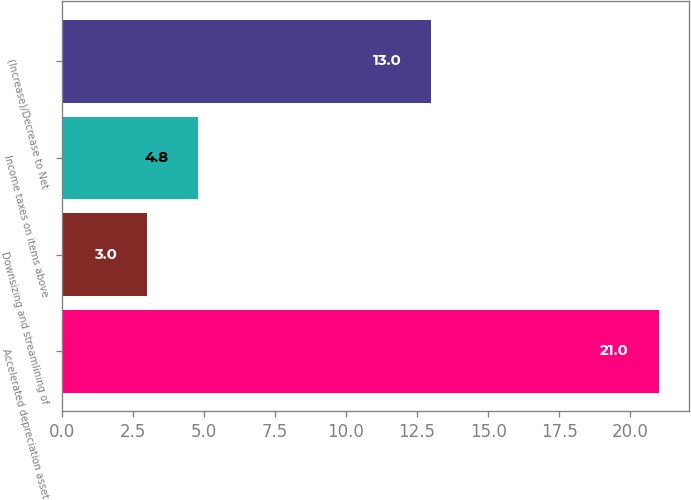Convert chart. <chart><loc_0><loc_0><loc_500><loc_500><bar_chart><fcel>Accelerated depreciation asset<fcel>Downsizing and streamlining of<fcel>Income taxes on items above<fcel>(Increase)/Decrease to Net<nl><fcel>21<fcel>3<fcel>4.8<fcel>13<nl></chart> 